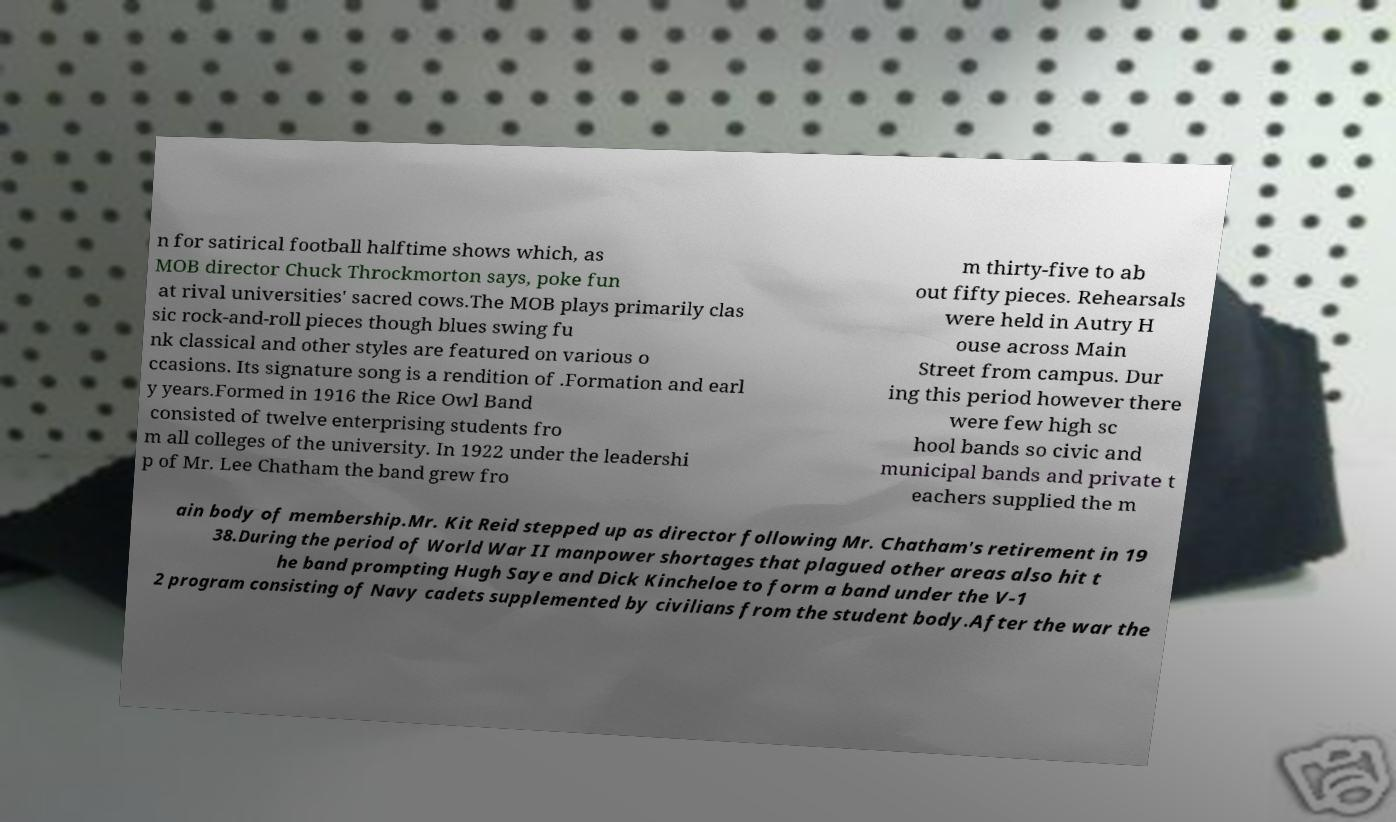What messages or text are displayed in this image? I need them in a readable, typed format. n for satirical football halftime shows which, as MOB director Chuck Throckmorton says, poke fun at rival universities' sacred cows.The MOB plays primarily clas sic rock-and-roll pieces though blues swing fu nk classical and other styles are featured on various o ccasions. Its signature song is a rendition of .Formation and earl y years.Formed in 1916 the Rice Owl Band consisted of twelve enterprising students fro m all colleges of the university. In 1922 under the leadershi p of Mr. Lee Chatham the band grew fro m thirty-five to ab out fifty pieces. Rehearsals were held in Autry H ouse across Main Street from campus. Dur ing this period however there were few high sc hool bands so civic and municipal bands and private t eachers supplied the m ain body of membership.Mr. Kit Reid stepped up as director following Mr. Chatham's retirement in 19 38.During the period of World War II manpower shortages that plagued other areas also hit t he band prompting Hugh Saye and Dick Kincheloe to form a band under the V-1 2 program consisting of Navy cadets supplemented by civilians from the student body.After the war the 